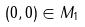<formula> <loc_0><loc_0><loc_500><loc_500>( 0 , 0 ) \in M _ { 1 }</formula> 